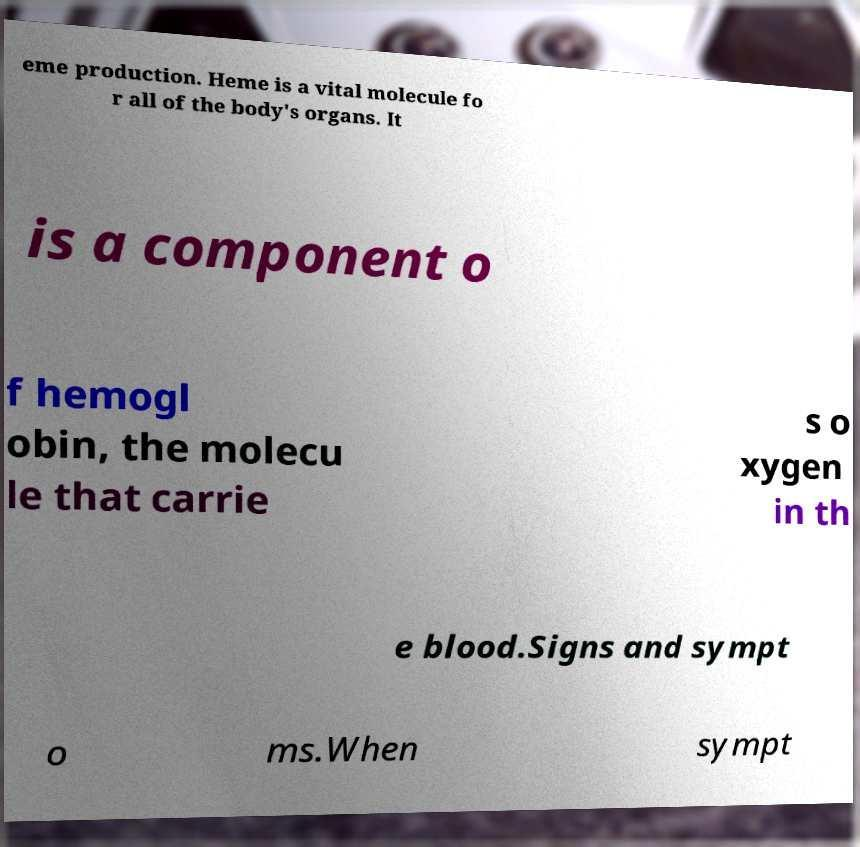Could you assist in decoding the text presented in this image and type it out clearly? eme production. Heme is a vital molecule fo r all of the body's organs. It is a component o f hemogl obin, the molecu le that carrie s o xygen in th e blood.Signs and sympt o ms.When sympt 